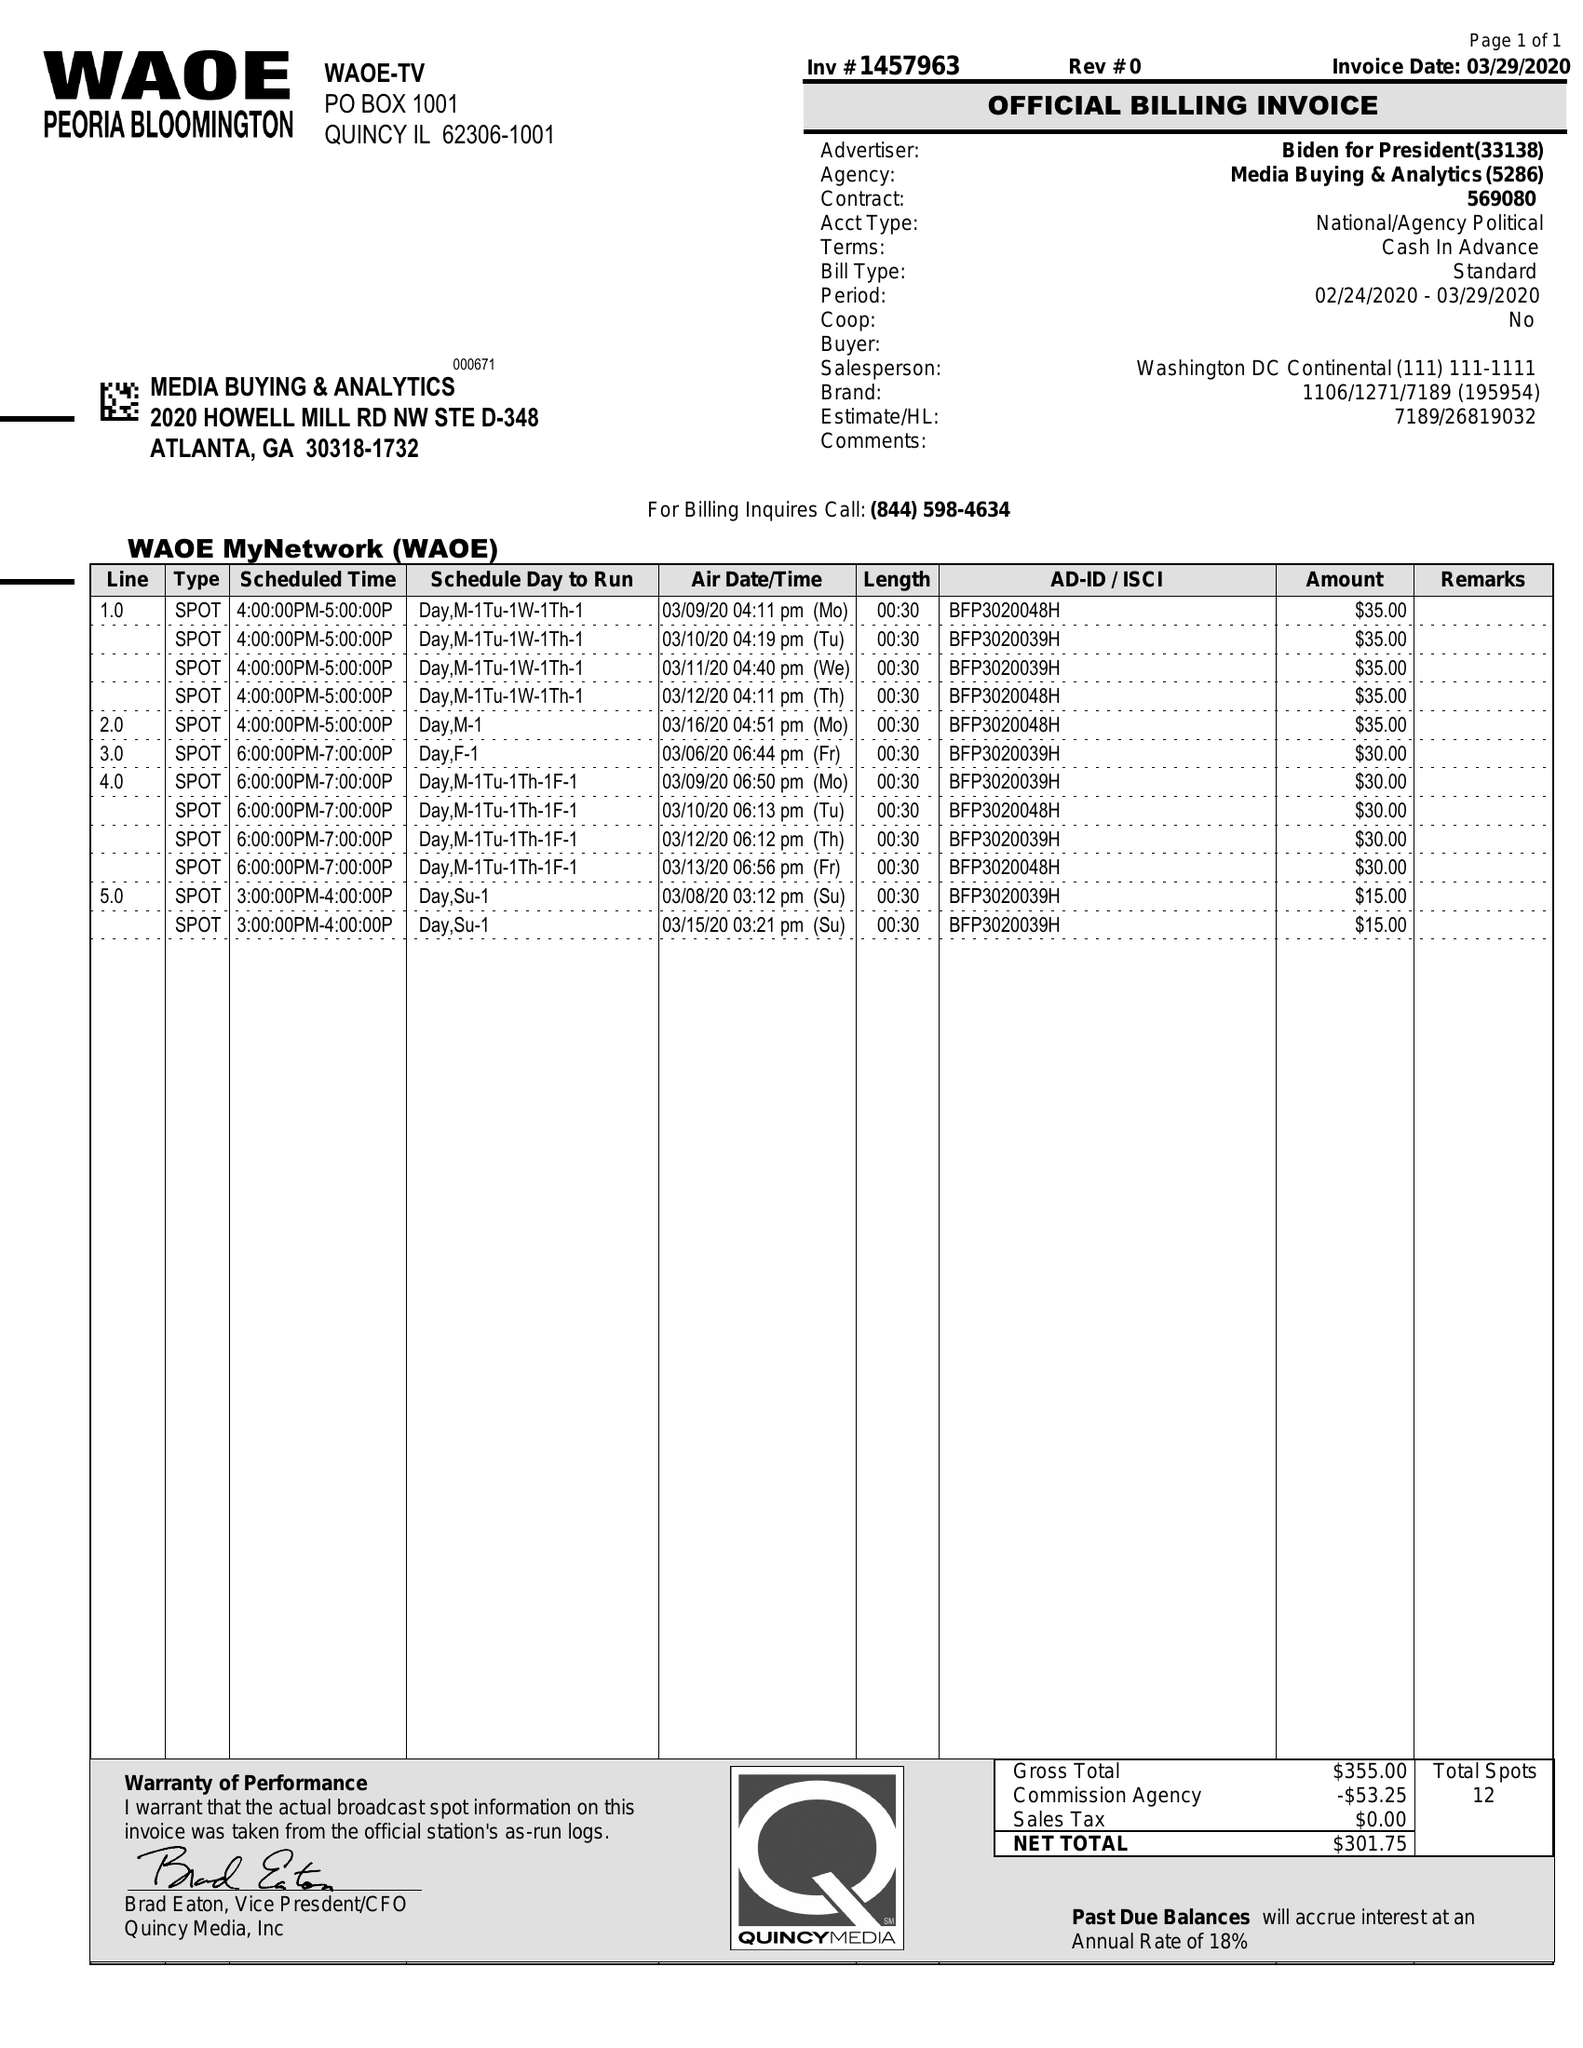What is the value for the contract_num?
Answer the question using a single word or phrase. 1457963 